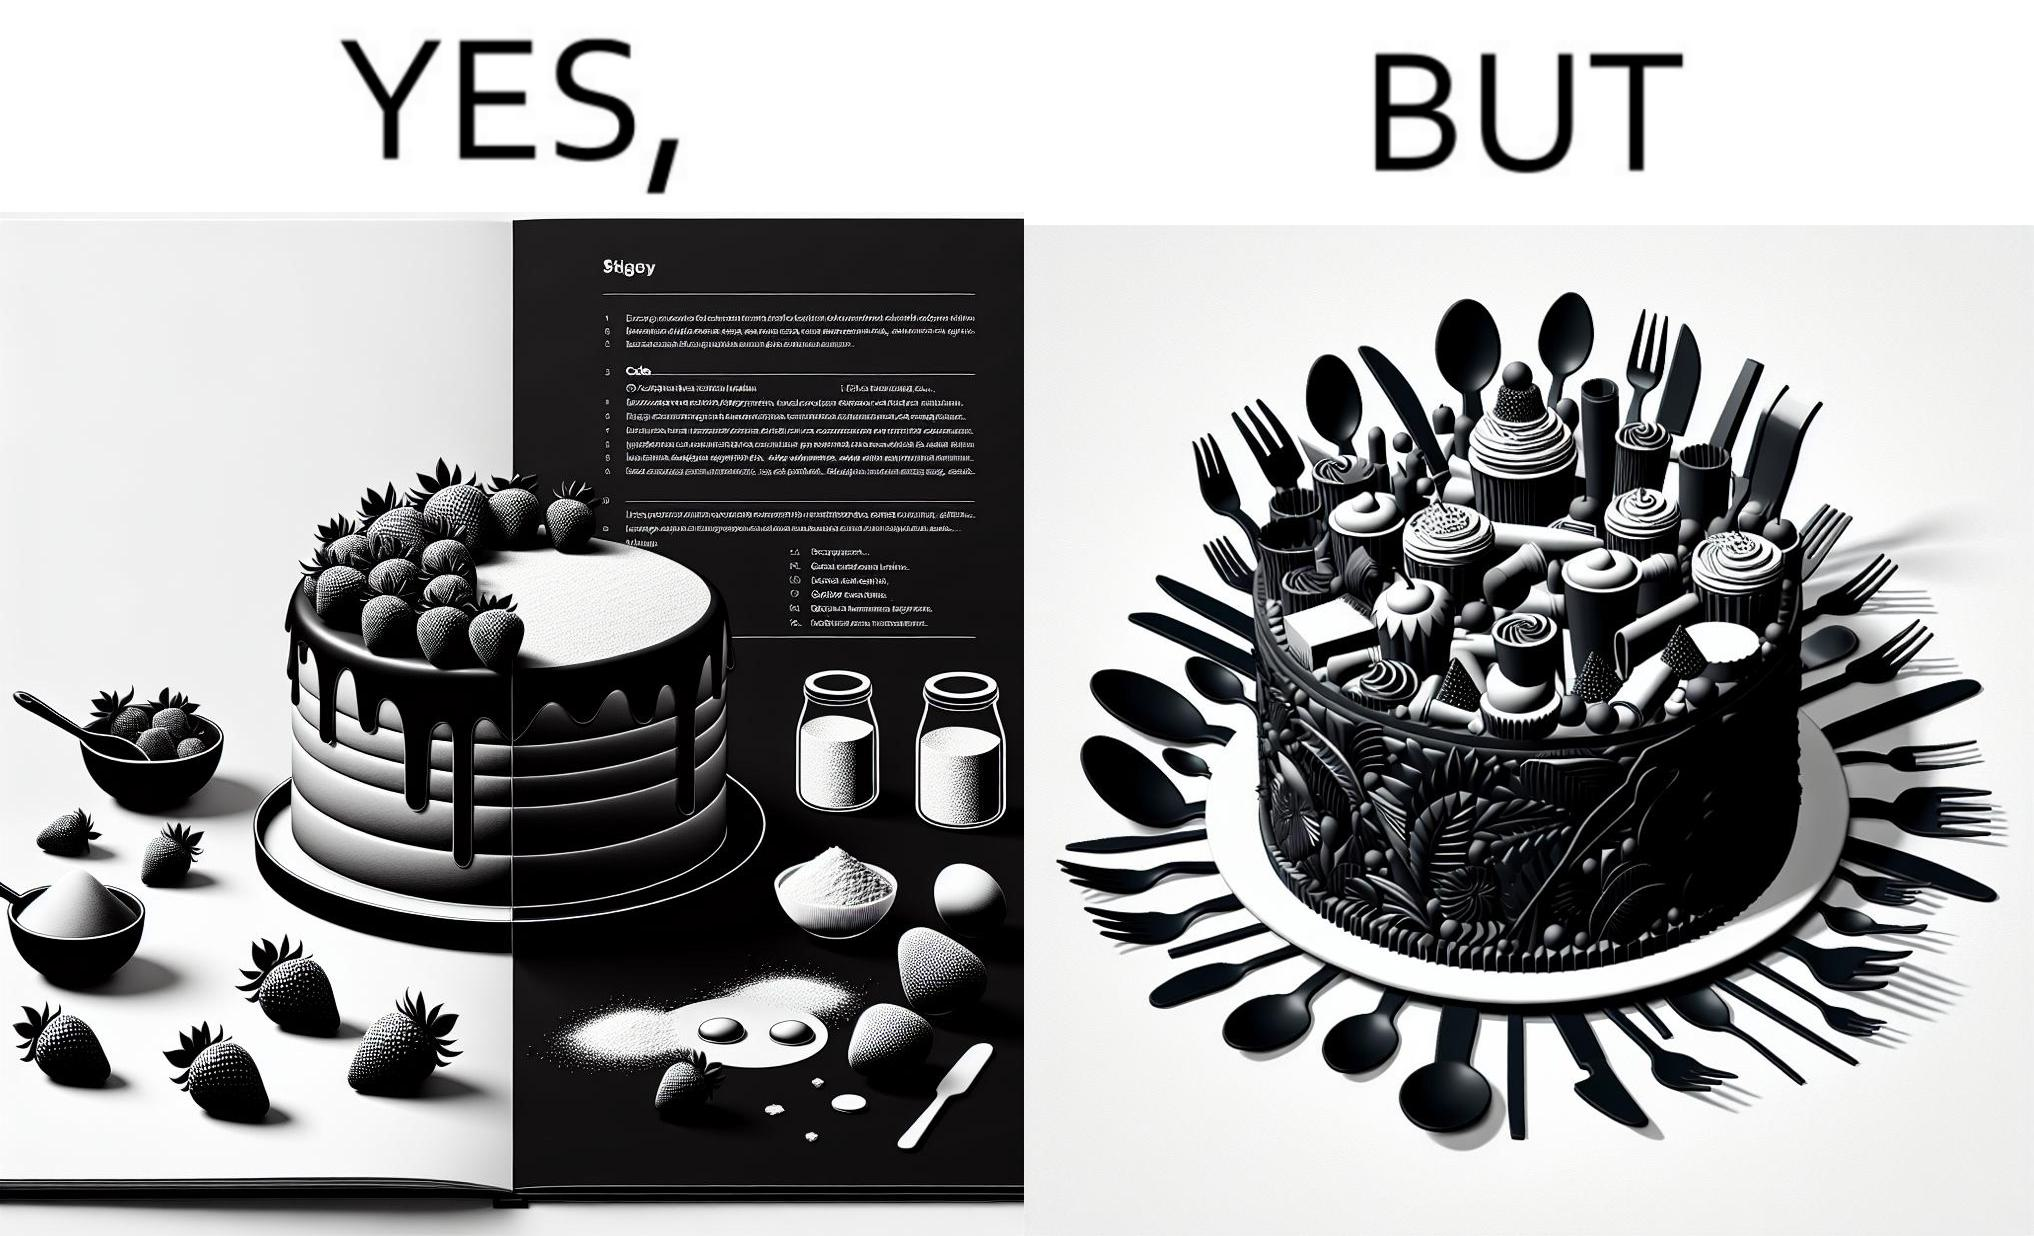Describe what you see in the left and right parts of this image. In the left part of the image: a page of a book showing the image of a strawberry cake, along with its ingredients. In the right part of the image: a cake on a plate, along with a bunch of used utensils to be washed. 